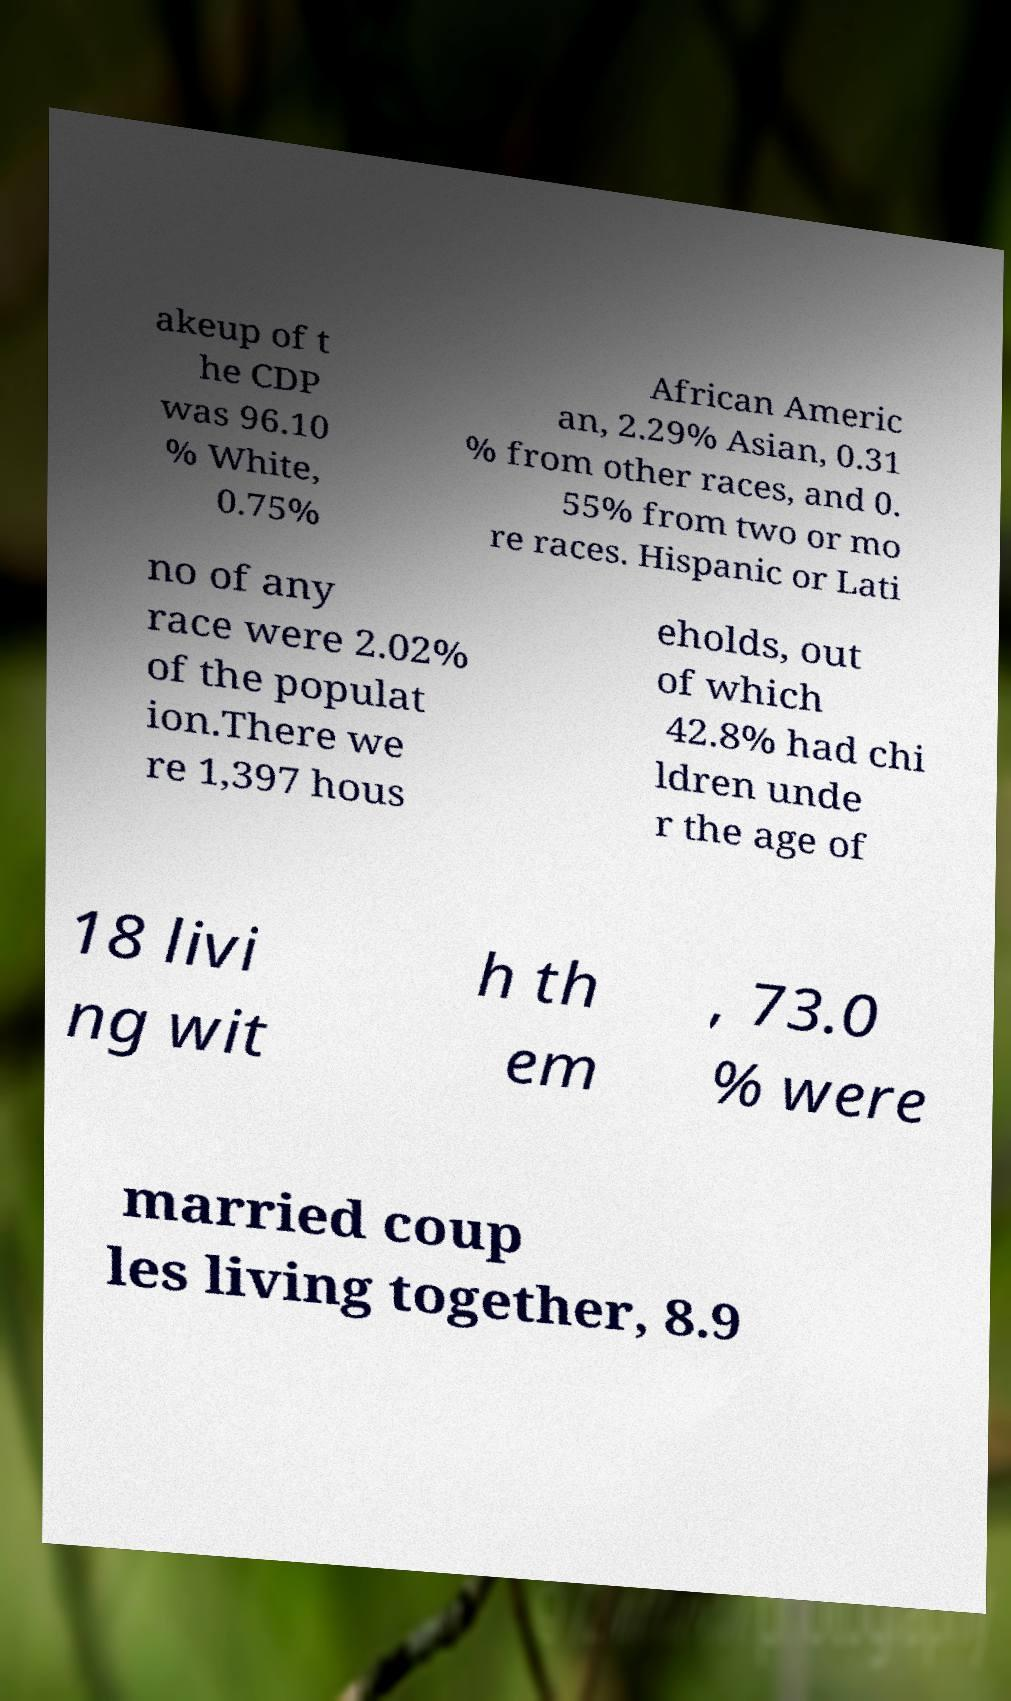Can you read and provide the text displayed in the image?This photo seems to have some interesting text. Can you extract and type it out for me? akeup of t he CDP was 96.10 % White, 0.75% African Americ an, 2.29% Asian, 0.31 % from other races, and 0. 55% from two or mo re races. Hispanic or Lati no of any race were 2.02% of the populat ion.There we re 1,397 hous eholds, out of which 42.8% had chi ldren unde r the age of 18 livi ng wit h th em , 73.0 % were married coup les living together, 8.9 